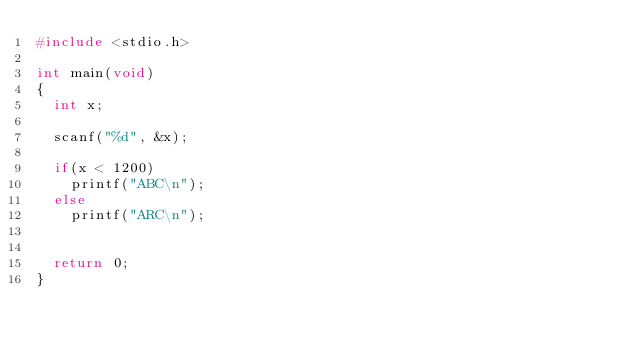Convert code to text. <code><loc_0><loc_0><loc_500><loc_500><_C_>#include <stdio.h>

int main(void)
{
	int x;
	
	scanf("%d", &x);
	
	if(x < 1200)
		printf("ABC\n");
	else
		printf("ARC\n");
	
	
	return 0;
}
</code> 